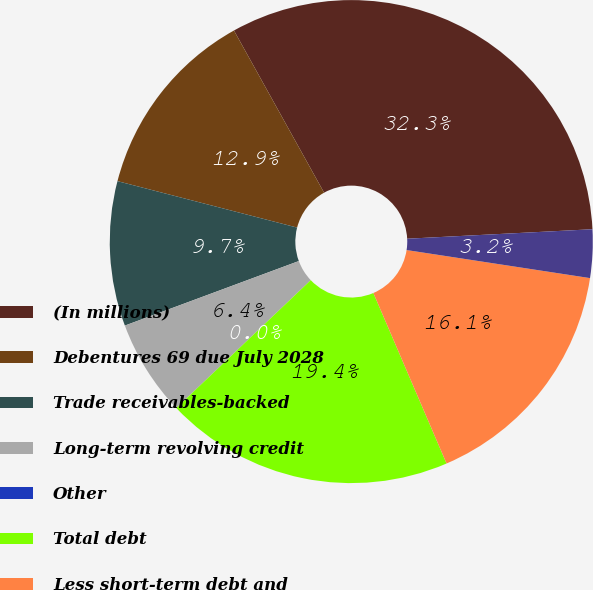Convert chart to OTSL. <chart><loc_0><loc_0><loc_500><loc_500><pie_chart><fcel>(In millions)<fcel>Debentures 69 due July 2028<fcel>Trade receivables-backed<fcel>Long-term revolving credit<fcel>Other<fcel>Total debt<fcel>Less short-term debt and<fcel>Less unamortized discounts<nl><fcel>32.26%<fcel>12.9%<fcel>9.68%<fcel>6.45%<fcel>0.0%<fcel>19.35%<fcel>16.13%<fcel>3.23%<nl></chart> 